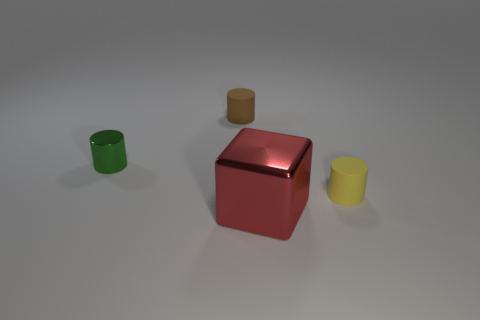Add 2 purple metal cylinders. How many objects exist? 6 Subtract all blocks. How many objects are left? 3 Add 2 yellow things. How many yellow things exist? 3 Subtract 0 cyan balls. How many objects are left? 4 Subtract all big purple metallic cubes. Subtract all green metal objects. How many objects are left? 3 Add 3 tiny brown rubber cylinders. How many tiny brown rubber cylinders are left? 4 